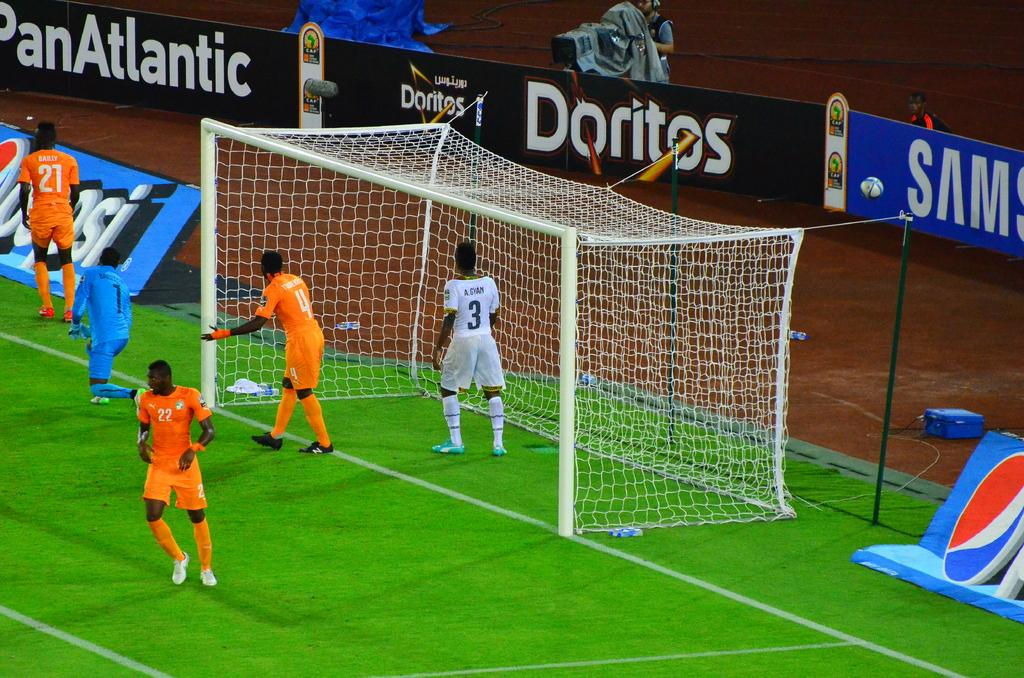Provide a one-sentence caption for the provided image. The home team at this soccer game is sponsored by PanAtlantic, Doritos, and Samsung. 